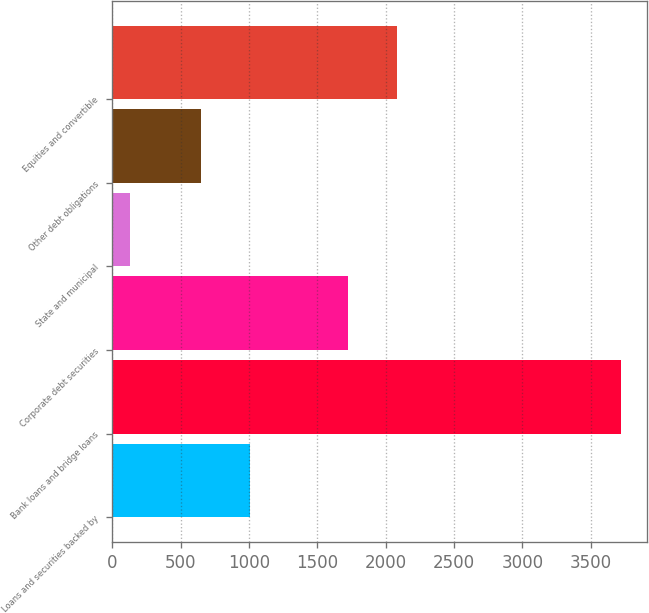Convert chart to OTSL. <chart><loc_0><loc_0><loc_500><loc_500><bar_chart><fcel>Loans and securities backed by<fcel>Bank loans and bridge loans<fcel>Corporate debt securities<fcel>State and municipal<fcel>Other debt obligations<fcel>Equities and convertible<nl><fcel>1007.1<fcel>3725<fcel>1725.3<fcel>134<fcel>648<fcel>2084.4<nl></chart> 